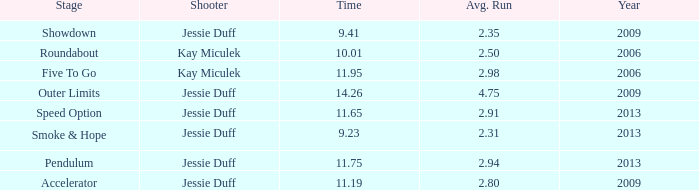What is the total amount of time for years prior to 2013 when speed option is the stage? None. 